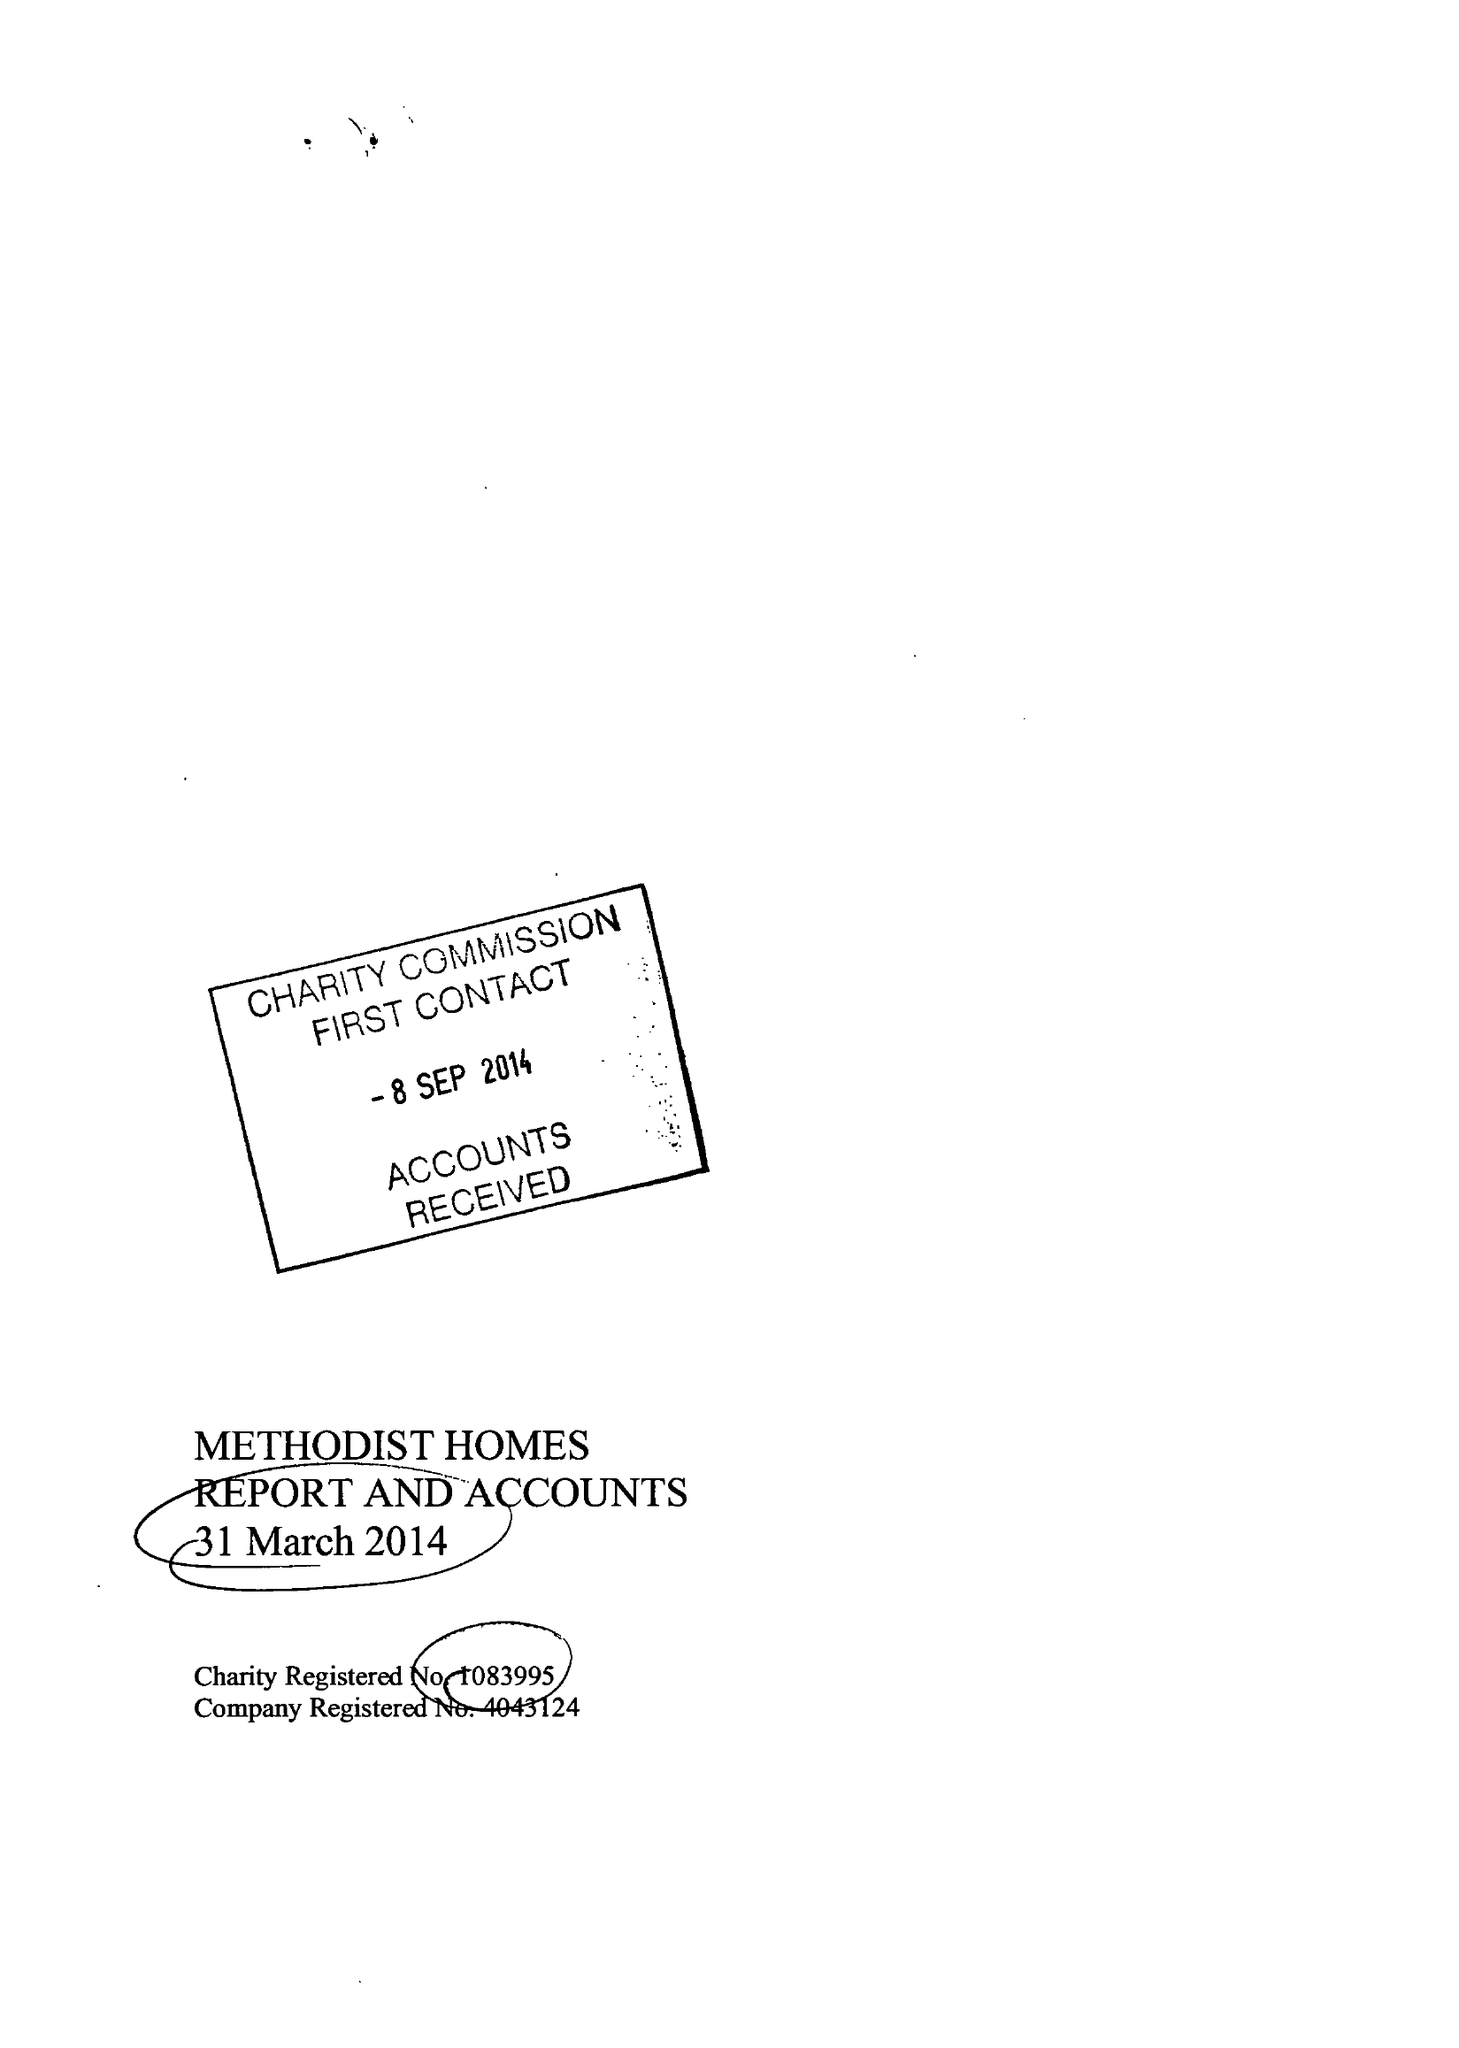What is the value for the address__street_line?
Answer the question using a single word or phrase. STUART STREET 